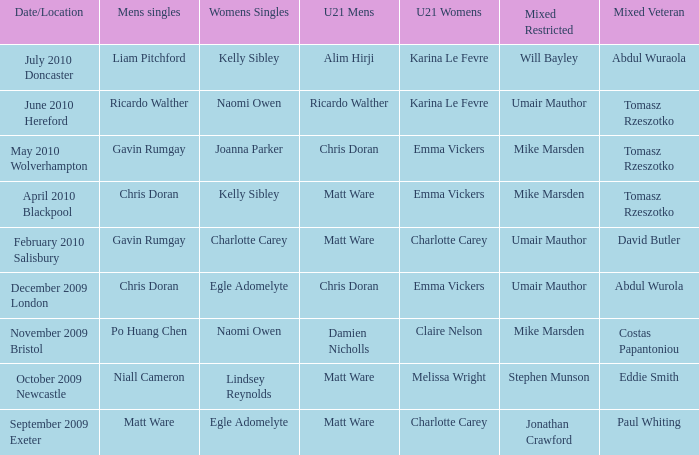When Matt Ware won the mens singles, who won the mixed restricted? Jonathan Crawford. 